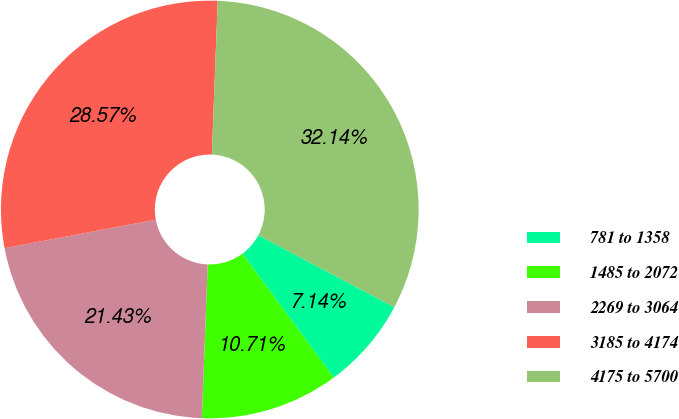<chart> <loc_0><loc_0><loc_500><loc_500><pie_chart><fcel>781 to 1358<fcel>1485 to 2072<fcel>2269 to 3064<fcel>3185 to 4174<fcel>4175 to 5700<nl><fcel>7.14%<fcel>10.71%<fcel>21.43%<fcel>28.57%<fcel>32.14%<nl></chart> 